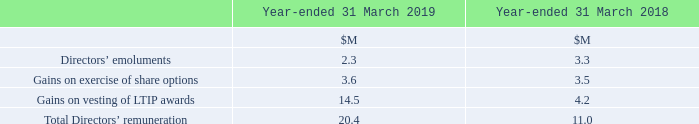12 Directors’ Remuneration
Directors’ emoluments represent all earnings and aggregate contributions to pension schemes made during the year as a Director of Sophos Group plc and its subsidiaries. Further details can be found in the Group’s Remuneration Report on pages 91 to 101.
What do the directors' emoluments represent? All earnings and aggregate contributions to pension schemes made during the year as a director of sophos group plc and its subsidiaries. Where can further details of the directors' emoluments be found? In the group’s remuneration report on pages 91 to 101. What are the components considered when calculating the total directors' remuneration? Directors’ emoluments, gains on exercise of share options, gains on vesting of ltip awards. In which year was the amount of Gains on exercise of share options larger? 3.6>3.5
Answer: 2019. What was the change in Total Directors’ remuneration in 2019 from 2018?
Answer scale should be: million. 20.4-11.0
Answer: 9.4. What was the percentage change in Total Directors’ remuneration in 2019 from 2018?
Answer scale should be: percent. (20.4-11.0)/11.0
Answer: 85.45. 